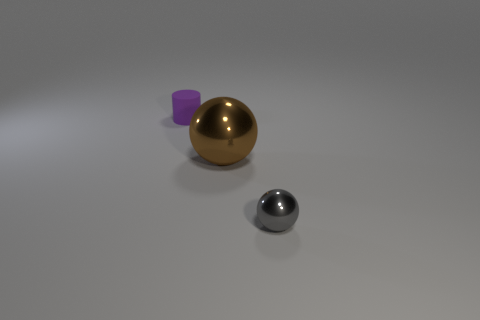Do the gray object and the big object have the same material?
Offer a very short reply. Yes. The other thing that is the same shape as the big brown metallic object is what size?
Your answer should be compact. Small. There is a object that is behind the small gray thing and in front of the matte cylinder; what is its material?
Make the answer very short. Metal. Is the number of big balls in front of the brown metal sphere the same as the number of large purple balls?
Provide a short and direct response. Yes. How many things are either shiny objects behind the tiny gray shiny thing or red matte cylinders?
Your answer should be compact. 1. There is a metallic object left of the small shiny sphere; what is its size?
Provide a short and direct response. Large. What shape is the metallic thing behind the tiny object that is in front of the cylinder?
Provide a short and direct response. Sphere. What color is the other big thing that is the same shape as the gray metal object?
Your answer should be compact. Brown. Do the metal sphere that is on the right side of the brown metal sphere and the tiny purple matte object have the same size?
Your answer should be very brief. Yes. How many other brown balls have the same material as the small sphere?
Ensure brevity in your answer.  1. 